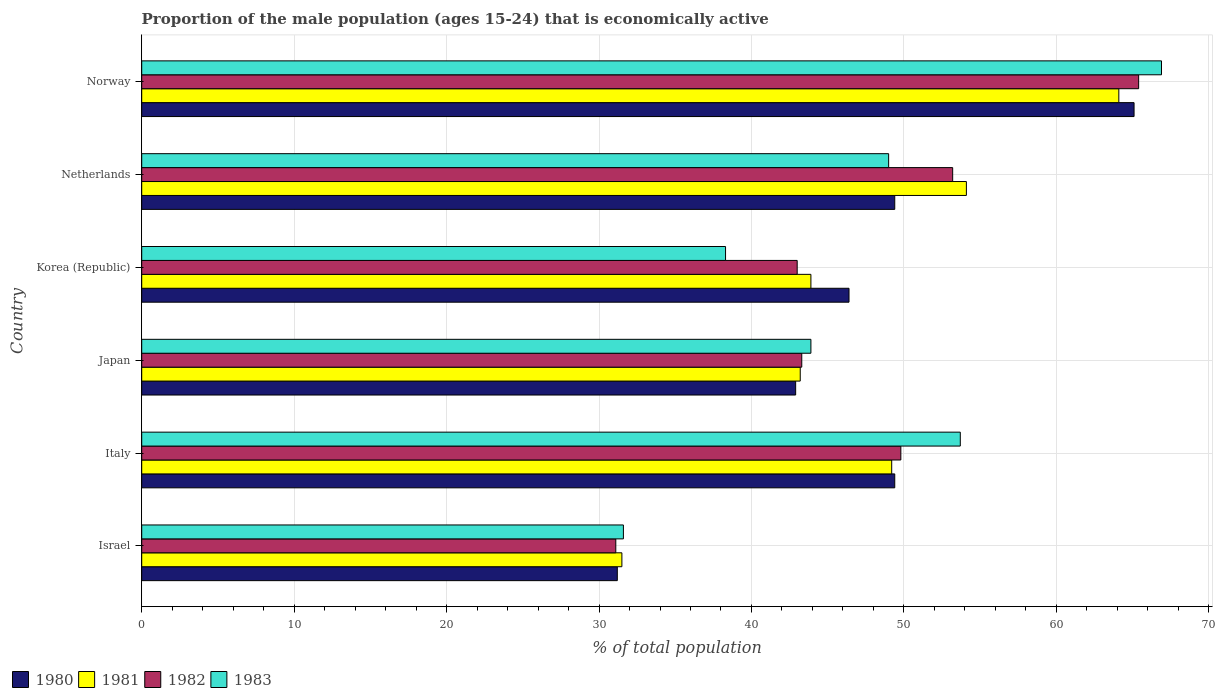How many different coloured bars are there?
Offer a terse response. 4. How many groups of bars are there?
Provide a succinct answer. 6. Are the number of bars per tick equal to the number of legend labels?
Your response must be concise. Yes. How many bars are there on the 3rd tick from the top?
Your answer should be compact. 4. What is the proportion of the male population that is economically active in 1980 in Israel?
Provide a succinct answer. 31.2. Across all countries, what is the maximum proportion of the male population that is economically active in 1983?
Provide a succinct answer. 66.9. Across all countries, what is the minimum proportion of the male population that is economically active in 1980?
Your answer should be very brief. 31.2. In which country was the proportion of the male population that is economically active in 1980 maximum?
Your answer should be very brief. Norway. In which country was the proportion of the male population that is economically active in 1983 minimum?
Provide a succinct answer. Israel. What is the total proportion of the male population that is economically active in 1981 in the graph?
Your response must be concise. 286. What is the difference between the proportion of the male population that is economically active in 1981 in Israel and that in Netherlands?
Give a very brief answer. -22.6. What is the difference between the proportion of the male population that is economically active in 1981 in Italy and the proportion of the male population that is economically active in 1983 in Norway?
Ensure brevity in your answer.  -17.7. What is the average proportion of the male population that is economically active in 1980 per country?
Keep it short and to the point. 47.4. What is the difference between the proportion of the male population that is economically active in 1982 and proportion of the male population that is economically active in 1983 in Norway?
Make the answer very short. -1.5. What is the ratio of the proportion of the male population that is economically active in 1982 in Japan to that in Korea (Republic)?
Provide a short and direct response. 1.01. Is the proportion of the male population that is economically active in 1981 in Italy less than that in Japan?
Keep it short and to the point. No. Is the difference between the proportion of the male population that is economically active in 1982 in Italy and Japan greater than the difference between the proportion of the male population that is economically active in 1983 in Italy and Japan?
Keep it short and to the point. No. What is the difference between the highest and the second highest proportion of the male population that is economically active in 1983?
Make the answer very short. 13.2. What is the difference between the highest and the lowest proportion of the male population that is economically active in 1982?
Provide a succinct answer. 34.3. In how many countries, is the proportion of the male population that is economically active in 1983 greater than the average proportion of the male population that is economically active in 1983 taken over all countries?
Your answer should be compact. 3. Is the sum of the proportion of the male population that is economically active in 1983 in Israel and Japan greater than the maximum proportion of the male population that is economically active in 1982 across all countries?
Provide a short and direct response. Yes. Is it the case that in every country, the sum of the proportion of the male population that is economically active in 1983 and proportion of the male population that is economically active in 1980 is greater than the sum of proportion of the male population that is economically active in 1981 and proportion of the male population that is economically active in 1982?
Provide a succinct answer. No. What does the 2nd bar from the top in Israel represents?
Make the answer very short. 1982. Are the values on the major ticks of X-axis written in scientific E-notation?
Your answer should be very brief. No. Does the graph contain grids?
Offer a terse response. Yes. How are the legend labels stacked?
Provide a succinct answer. Horizontal. What is the title of the graph?
Your answer should be very brief. Proportion of the male population (ages 15-24) that is economically active. What is the label or title of the X-axis?
Your answer should be very brief. % of total population. What is the label or title of the Y-axis?
Ensure brevity in your answer.  Country. What is the % of total population in 1980 in Israel?
Your answer should be very brief. 31.2. What is the % of total population in 1981 in Israel?
Provide a short and direct response. 31.5. What is the % of total population in 1982 in Israel?
Your answer should be compact. 31.1. What is the % of total population of 1983 in Israel?
Give a very brief answer. 31.6. What is the % of total population in 1980 in Italy?
Ensure brevity in your answer.  49.4. What is the % of total population in 1981 in Italy?
Give a very brief answer. 49.2. What is the % of total population in 1982 in Italy?
Keep it short and to the point. 49.8. What is the % of total population in 1983 in Italy?
Your answer should be compact. 53.7. What is the % of total population in 1980 in Japan?
Make the answer very short. 42.9. What is the % of total population of 1981 in Japan?
Provide a succinct answer. 43.2. What is the % of total population of 1982 in Japan?
Provide a succinct answer. 43.3. What is the % of total population in 1983 in Japan?
Offer a very short reply. 43.9. What is the % of total population in 1980 in Korea (Republic)?
Make the answer very short. 46.4. What is the % of total population in 1981 in Korea (Republic)?
Provide a succinct answer. 43.9. What is the % of total population in 1982 in Korea (Republic)?
Give a very brief answer. 43. What is the % of total population in 1983 in Korea (Republic)?
Ensure brevity in your answer.  38.3. What is the % of total population in 1980 in Netherlands?
Keep it short and to the point. 49.4. What is the % of total population in 1981 in Netherlands?
Your answer should be compact. 54.1. What is the % of total population in 1982 in Netherlands?
Provide a succinct answer. 53.2. What is the % of total population of 1983 in Netherlands?
Provide a short and direct response. 49. What is the % of total population of 1980 in Norway?
Provide a succinct answer. 65.1. What is the % of total population in 1981 in Norway?
Your answer should be compact. 64.1. What is the % of total population in 1982 in Norway?
Provide a succinct answer. 65.4. What is the % of total population in 1983 in Norway?
Your response must be concise. 66.9. Across all countries, what is the maximum % of total population of 1980?
Provide a short and direct response. 65.1. Across all countries, what is the maximum % of total population of 1981?
Give a very brief answer. 64.1. Across all countries, what is the maximum % of total population in 1982?
Ensure brevity in your answer.  65.4. Across all countries, what is the maximum % of total population of 1983?
Provide a short and direct response. 66.9. Across all countries, what is the minimum % of total population of 1980?
Your answer should be compact. 31.2. Across all countries, what is the minimum % of total population of 1981?
Offer a very short reply. 31.5. Across all countries, what is the minimum % of total population in 1982?
Keep it short and to the point. 31.1. Across all countries, what is the minimum % of total population of 1983?
Ensure brevity in your answer.  31.6. What is the total % of total population in 1980 in the graph?
Keep it short and to the point. 284.4. What is the total % of total population of 1981 in the graph?
Give a very brief answer. 286. What is the total % of total population in 1982 in the graph?
Give a very brief answer. 285.8. What is the total % of total population of 1983 in the graph?
Provide a short and direct response. 283.4. What is the difference between the % of total population in 1980 in Israel and that in Italy?
Offer a very short reply. -18.2. What is the difference between the % of total population in 1981 in Israel and that in Italy?
Give a very brief answer. -17.7. What is the difference between the % of total population in 1982 in Israel and that in Italy?
Offer a terse response. -18.7. What is the difference between the % of total population of 1983 in Israel and that in Italy?
Keep it short and to the point. -22.1. What is the difference between the % of total population of 1980 in Israel and that in Japan?
Your answer should be compact. -11.7. What is the difference between the % of total population of 1981 in Israel and that in Japan?
Give a very brief answer. -11.7. What is the difference between the % of total population of 1982 in Israel and that in Japan?
Offer a terse response. -12.2. What is the difference between the % of total population in 1983 in Israel and that in Japan?
Your answer should be very brief. -12.3. What is the difference between the % of total population in 1980 in Israel and that in Korea (Republic)?
Your answer should be compact. -15.2. What is the difference between the % of total population of 1982 in Israel and that in Korea (Republic)?
Give a very brief answer. -11.9. What is the difference between the % of total population in 1983 in Israel and that in Korea (Republic)?
Ensure brevity in your answer.  -6.7. What is the difference between the % of total population in 1980 in Israel and that in Netherlands?
Make the answer very short. -18.2. What is the difference between the % of total population in 1981 in Israel and that in Netherlands?
Make the answer very short. -22.6. What is the difference between the % of total population in 1982 in Israel and that in Netherlands?
Make the answer very short. -22.1. What is the difference between the % of total population in 1983 in Israel and that in Netherlands?
Ensure brevity in your answer.  -17.4. What is the difference between the % of total population of 1980 in Israel and that in Norway?
Keep it short and to the point. -33.9. What is the difference between the % of total population in 1981 in Israel and that in Norway?
Your answer should be very brief. -32.6. What is the difference between the % of total population of 1982 in Israel and that in Norway?
Offer a terse response. -34.3. What is the difference between the % of total population of 1983 in Israel and that in Norway?
Your answer should be compact. -35.3. What is the difference between the % of total population of 1980 in Italy and that in Japan?
Offer a very short reply. 6.5. What is the difference between the % of total population of 1982 in Italy and that in Japan?
Make the answer very short. 6.5. What is the difference between the % of total population in 1983 in Italy and that in Japan?
Your response must be concise. 9.8. What is the difference between the % of total population of 1980 in Italy and that in Korea (Republic)?
Offer a terse response. 3. What is the difference between the % of total population in 1983 in Italy and that in Netherlands?
Make the answer very short. 4.7. What is the difference between the % of total population in 1980 in Italy and that in Norway?
Provide a short and direct response. -15.7. What is the difference between the % of total population of 1981 in Italy and that in Norway?
Make the answer very short. -14.9. What is the difference between the % of total population of 1982 in Italy and that in Norway?
Provide a succinct answer. -15.6. What is the difference between the % of total population of 1981 in Japan and that in Korea (Republic)?
Ensure brevity in your answer.  -0.7. What is the difference between the % of total population in 1982 in Japan and that in Korea (Republic)?
Your response must be concise. 0.3. What is the difference between the % of total population in 1982 in Japan and that in Netherlands?
Provide a short and direct response. -9.9. What is the difference between the % of total population of 1983 in Japan and that in Netherlands?
Your answer should be very brief. -5.1. What is the difference between the % of total population in 1980 in Japan and that in Norway?
Your answer should be compact. -22.2. What is the difference between the % of total population in 1981 in Japan and that in Norway?
Provide a short and direct response. -20.9. What is the difference between the % of total population in 1982 in Japan and that in Norway?
Offer a very short reply. -22.1. What is the difference between the % of total population in 1981 in Korea (Republic) and that in Netherlands?
Give a very brief answer. -10.2. What is the difference between the % of total population of 1982 in Korea (Republic) and that in Netherlands?
Keep it short and to the point. -10.2. What is the difference between the % of total population of 1980 in Korea (Republic) and that in Norway?
Keep it short and to the point. -18.7. What is the difference between the % of total population in 1981 in Korea (Republic) and that in Norway?
Offer a very short reply. -20.2. What is the difference between the % of total population of 1982 in Korea (Republic) and that in Norway?
Your answer should be very brief. -22.4. What is the difference between the % of total population in 1983 in Korea (Republic) and that in Norway?
Keep it short and to the point. -28.6. What is the difference between the % of total population of 1980 in Netherlands and that in Norway?
Provide a succinct answer. -15.7. What is the difference between the % of total population in 1981 in Netherlands and that in Norway?
Give a very brief answer. -10. What is the difference between the % of total population in 1983 in Netherlands and that in Norway?
Provide a short and direct response. -17.9. What is the difference between the % of total population in 1980 in Israel and the % of total population in 1982 in Italy?
Offer a very short reply. -18.6. What is the difference between the % of total population in 1980 in Israel and the % of total population in 1983 in Italy?
Ensure brevity in your answer.  -22.5. What is the difference between the % of total population in 1981 in Israel and the % of total population in 1982 in Italy?
Ensure brevity in your answer.  -18.3. What is the difference between the % of total population of 1981 in Israel and the % of total population of 1983 in Italy?
Provide a short and direct response. -22.2. What is the difference between the % of total population in 1982 in Israel and the % of total population in 1983 in Italy?
Give a very brief answer. -22.6. What is the difference between the % of total population in 1980 in Israel and the % of total population in 1981 in Japan?
Provide a succinct answer. -12. What is the difference between the % of total population in 1980 in Israel and the % of total population in 1982 in Japan?
Provide a succinct answer. -12.1. What is the difference between the % of total population of 1981 in Israel and the % of total population of 1983 in Japan?
Ensure brevity in your answer.  -12.4. What is the difference between the % of total population in 1982 in Israel and the % of total population in 1983 in Japan?
Provide a succinct answer. -12.8. What is the difference between the % of total population of 1980 in Israel and the % of total population of 1981 in Korea (Republic)?
Your answer should be very brief. -12.7. What is the difference between the % of total population of 1980 in Israel and the % of total population of 1983 in Korea (Republic)?
Your answer should be compact. -7.1. What is the difference between the % of total population of 1982 in Israel and the % of total population of 1983 in Korea (Republic)?
Your answer should be very brief. -7.2. What is the difference between the % of total population in 1980 in Israel and the % of total population in 1981 in Netherlands?
Make the answer very short. -22.9. What is the difference between the % of total population in 1980 in Israel and the % of total population in 1983 in Netherlands?
Offer a terse response. -17.8. What is the difference between the % of total population of 1981 in Israel and the % of total population of 1982 in Netherlands?
Your answer should be compact. -21.7. What is the difference between the % of total population of 1981 in Israel and the % of total population of 1983 in Netherlands?
Give a very brief answer. -17.5. What is the difference between the % of total population in 1982 in Israel and the % of total population in 1983 in Netherlands?
Ensure brevity in your answer.  -17.9. What is the difference between the % of total population in 1980 in Israel and the % of total population in 1981 in Norway?
Provide a succinct answer. -32.9. What is the difference between the % of total population of 1980 in Israel and the % of total population of 1982 in Norway?
Your answer should be compact. -34.2. What is the difference between the % of total population of 1980 in Israel and the % of total population of 1983 in Norway?
Make the answer very short. -35.7. What is the difference between the % of total population of 1981 in Israel and the % of total population of 1982 in Norway?
Offer a very short reply. -33.9. What is the difference between the % of total population of 1981 in Israel and the % of total population of 1983 in Norway?
Your answer should be very brief. -35.4. What is the difference between the % of total population of 1982 in Israel and the % of total population of 1983 in Norway?
Provide a succinct answer. -35.8. What is the difference between the % of total population in 1982 in Italy and the % of total population in 1983 in Japan?
Make the answer very short. 5.9. What is the difference between the % of total population of 1980 in Italy and the % of total population of 1981 in Korea (Republic)?
Provide a succinct answer. 5.5. What is the difference between the % of total population in 1980 in Italy and the % of total population in 1982 in Korea (Republic)?
Make the answer very short. 6.4. What is the difference between the % of total population of 1981 in Italy and the % of total population of 1983 in Korea (Republic)?
Your answer should be very brief. 10.9. What is the difference between the % of total population of 1980 in Italy and the % of total population of 1983 in Netherlands?
Your answer should be very brief. 0.4. What is the difference between the % of total population of 1981 in Italy and the % of total population of 1982 in Netherlands?
Provide a short and direct response. -4. What is the difference between the % of total population in 1981 in Italy and the % of total population in 1983 in Netherlands?
Your response must be concise. 0.2. What is the difference between the % of total population in 1980 in Italy and the % of total population in 1981 in Norway?
Keep it short and to the point. -14.7. What is the difference between the % of total population in 1980 in Italy and the % of total population in 1983 in Norway?
Your response must be concise. -17.5. What is the difference between the % of total population in 1981 in Italy and the % of total population in 1982 in Norway?
Your answer should be very brief. -16.2. What is the difference between the % of total population in 1981 in Italy and the % of total population in 1983 in Norway?
Provide a succinct answer. -17.7. What is the difference between the % of total population in 1982 in Italy and the % of total population in 1983 in Norway?
Ensure brevity in your answer.  -17.1. What is the difference between the % of total population in 1980 in Japan and the % of total population in 1982 in Korea (Republic)?
Provide a succinct answer. -0.1. What is the difference between the % of total population in 1980 in Japan and the % of total population in 1981 in Netherlands?
Offer a terse response. -11.2. What is the difference between the % of total population of 1980 in Japan and the % of total population of 1982 in Netherlands?
Offer a terse response. -10.3. What is the difference between the % of total population in 1980 in Japan and the % of total population in 1983 in Netherlands?
Your answer should be very brief. -6.1. What is the difference between the % of total population in 1981 in Japan and the % of total population in 1982 in Netherlands?
Give a very brief answer. -10. What is the difference between the % of total population of 1980 in Japan and the % of total population of 1981 in Norway?
Offer a very short reply. -21.2. What is the difference between the % of total population of 1980 in Japan and the % of total population of 1982 in Norway?
Ensure brevity in your answer.  -22.5. What is the difference between the % of total population of 1981 in Japan and the % of total population of 1982 in Norway?
Provide a short and direct response. -22.2. What is the difference between the % of total population in 1981 in Japan and the % of total population in 1983 in Norway?
Give a very brief answer. -23.7. What is the difference between the % of total population of 1982 in Japan and the % of total population of 1983 in Norway?
Make the answer very short. -23.6. What is the difference between the % of total population in 1980 in Korea (Republic) and the % of total population in 1982 in Netherlands?
Provide a short and direct response. -6.8. What is the difference between the % of total population of 1980 in Korea (Republic) and the % of total population of 1983 in Netherlands?
Your answer should be compact. -2.6. What is the difference between the % of total population of 1981 in Korea (Republic) and the % of total population of 1982 in Netherlands?
Keep it short and to the point. -9.3. What is the difference between the % of total population in 1982 in Korea (Republic) and the % of total population in 1983 in Netherlands?
Keep it short and to the point. -6. What is the difference between the % of total population in 1980 in Korea (Republic) and the % of total population in 1981 in Norway?
Provide a short and direct response. -17.7. What is the difference between the % of total population in 1980 in Korea (Republic) and the % of total population in 1983 in Norway?
Offer a terse response. -20.5. What is the difference between the % of total population in 1981 in Korea (Republic) and the % of total population in 1982 in Norway?
Provide a succinct answer. -21.5. What is the difference between the % of total population of 1982 in Korea (Republic) and the % of total population of 1983 in Norway?
Provide a succinct answer. -23.9. What is the difference between the % of total population in 1980 in Netherlands and the % of total population in 1981 in Norway?
Provide a short and direct response. -14.7. What is the difference between the % of total population in 1980 in Netherlands and the % of total population in 1983 in Norway?
Offer a terse response. -17.5. What is the difference between the % of total population in 1981 in Netherlands and the % of total population in 1982 in Norway?
Offer a terse response. -11.3. What is the difference between the % of total population of 1982 in Netherlands and the % of total population of 1983 in Norway?
Keep it short and to the point. -13.7. What is the average % of total population of 1980 per country?
Give a very brief answer. 47.4. What is the average % of total population of 1981 per country?
Make the answer very short. 47.67. What is the average % of total population of 1982 per country?
Ensure brevity in your answer.  47.63. What is the average % of total population of 1983 per country?
Offer a very short reply. 47.23. What is the difference between the % of total population in 1980 and % of total population in 1981 in Israel?
Make the answer very short. -0.3. What is the difference between the % of total population in 1980 and % of total population in 1983 in Israel?
Give a very brief answer. -0.4. What is the difference between the % of total population of 1981 and % of total population of 1982 in Israel?
Keep it short and to the point. 0.4. What is the difference between the % of total population of 1982 and % of total population of 1983 in Israel?
Your answer should be very brief. -0.5. What is the difference between the % of total population in 1980 and % of total population in 1982 in Italy?
Keep it short and to the point. -0.4. What is the difference between the % of total population in 1980 and % of total population in 1983 in Italy?
Ensure brevity in your answer.  -4.3. What is the difference between the % of total population in 1981 and % of total population in 1982 in Italy?
Your answer should be compact. -0.6. What is the difference between the % of total population in 1981 and % of total population in 1983 in Italy?
Your answer should be very brief. -4.5. What is the difference between the % of total population in 1982 and % of total population in 1983 in Italy?
Your answer should be very brief. -3.9. What is the difference between the % of total population in 1980 and % of total population in 1981 in Japan?
Your response must be concise. -0.3. What is the difference between the % of total population in 1981 and % of total population in 1982 in Japan?
Make the answer very short. -0.1. What is the difference between the % of total population in 1981 and % of total population in 1983 in Japan?
Offer a terse response. -0.7. What is the difference between the % of total population in 1982 and % of total population in 1983 in Japan?
Offer a very short reply. -0.6. What is the difference between the % of total population of 1980 and % of total population of 1983 in Korea (Republic)?
Provide a short and direct response. 8.1. What is the difference between the % of total population of 1981 and % of total population of 1983 in Korea (Republic)?
Your answer should be very brief. 5.6. What is the difference between the % of total population in 1980 and % of total population in 1981 in Netherlands?
Provide a succinct answer. -4.7. What is the difference between the % of total population in 1980 and % of total population in 1982 in Netherlands?
Keep it short and to the point. -3.8. What is the difference between the % of total population in 1981 and % of total population in 1983 in Netherlands?
Offer a very short reply. 5.1. What is the difference between the % of total population in 1980 and % of total population in 1981 in Norway?
Ensure brevity in your answer.  1. What is the difference between the % of total population of 1981 and % of total population of 1982 in Norway?
Your answer should be very brief. -1.3. What is the ratio of the % of total population of 1980 in Israel to that in Italy?
Your answer should be compact. 0.63. What is the ratio of the % of total population of 1981 in Israel to that in Italy?
Give a very brief answer. 0.64. What is the ratio of the % of total population of 1982 in Israel to that in Italy?
Offer a very short reply. 0.62. What is the ratio of the % of total population of 1983 in Israel to that in Italy?
Offer a terse response. 0.59. What is the ratio of the % of total population in 1980 in Israel to that in Japan?
Provide a succinct answer. 0.73. What is the ratio of the % of total population in 1981 in Israel to that in Japan?
Offer a very short reply. 0.73. What is the ratio of the % of total population in 1982 in Israel to that in Japan?
Provide a short and direct response. 0.72. What is the ratio of the % of total population in 1983 in Israel to that in Japan?
Give a very brief answer. 0.72. What is the ratio of the % of total population in 1980 in Israel to that in Korea (Republic)?
Offer a terse response. 0.67. What is the ratio of the % of total population in 1981 in Israel to that in Korea (Republic)?
Your answer should be compact. 0.72. What is the ratio of the % of total population of 1982 in Israel to that in Korea (Republic)?
Provide a short and direct response. 0.72. What is the ratio of the % of total population in 1983 in Israel to that in Korea (Republic)?
Give a very brief answer. 0.83. What is the ratio of the % of total population of 1980 in Israel to that in Netherlands?
Make the answer very short. 0.63. What is the ratio of the % of total population of 1981 in Israel to that in Netherlands?
Offer a very short reply. 0.58. What is the ratio of the % of total population of 1982 in Israel to that in Netherlands?
Offer a terse response. 0.58. What is the ratio of the % of total population of 1983 in Israel to that in Netherlands?
Keep it short and to the point. 0.64. What is the ratio of the % of total population in 1980 in Israel to that in Norway?
Your response must be concise. 0.48. What is the ratio of the % of total population of 1981 in Israel to that in Norway?
Offer a very short reply. 0.49. What is the ratio of the % of total population in 1982 in Israel to that in Norway?
Your response must be concise. 0.48. What is the ratio of the % of total population in 1983 in Israel to that in Norway?
Offer a very short reply. 0.47. What is the ratio of the % of total population in 1980 in Italy to that in Japan?
Ensure brevity in your answer.  1.15. What is the ratio of the % of total population of 1981 in Italy to that in Japan?
Provide a short and direct response. 1.14. What is the ratio of the % of total population in 1982 in Italy to that in Japan?
Keep it short and to the point. 1.15. What is the ratio of the % of total population of 1983 in Italy to that in Japan?
Your answer should be very brief. 1.22. What is the ratio of the % of total population in 1980 in Italy to that in Korea (Republic)?
Make the answer very short. 1.06. What is the ratio of the % of total population in 1981 in Italy to that in Korea (Republic)?
Provide a short and direct response. 1.12. What is the ratio of the % of total population of 1982 in Italy to that in Korea (Republic)?
Ensure brevity in your answer.  1.16. What is the ratio of the % of total population in 1983 in Italy to that in Korea (Republic)?
Provide a short and direct response. 1.4. What is the ratio of the % of total population in 1981 in Italy to that in Netherlands?
Ensure brevity in your answer.  0.91. What is the ratio of the % of total population in 1982 in Italy to that in Netherlands?
Keep it short and to the point. 0.94. What is the ratio of the % of total population of 1983 in Italy to that in Netherlands?
Give a very brief answer. 1.1. What is the ratio of the % of total population in 1980 in Italy to that in Norway?
Provide a succinct answer. 0.76. What is the ratio of the % of total population in 1981 in Italy to that in Norway?
Make the answer very short. 0.77. What is the ratio of the % of total population of 1982 in Italy to that in Norway?
Ensure brevity in your answer.  0.76. What is the ratio of the % of total population in 1983 in Italy to that in Norway?
Your answer should be very brief. 0.8. What is the ratio of the % of total population in 1980 in Japan to that in Korea (Republic)?
Provide a short and direct response. 0.92. What is the ratio of the % of total population in 1981 in Japan to that in Korea (Republic)?
Offer a terse response. 0.98. What is the ratio of the % of total population of 1982 in Japan to that in Korea (Republic)?
Give a very brief answer. 1.01. What is the ratio of the % of total population of 1983 in Japan to that in Korea (Republic)?
Your response must be concise. 1.15. What is the ratio of the % of total population in 1980 in Japan to that in Netherlands?
Ensure brevity in your answer.  0.87. What is the ratio of the % of total population in 1981 in Japan to that in Netherlands?
Offer a terse response. 0.8. What is the ratio of the % of total population in 1982 in Japan to that in Netherlands?
Offer a terse response. 0.81. What is the ratio of the % of total population of 1983 in Japan to that in Netherlands?
Offer a terse response. 0.9. What is the ratio of the % of total population of 1980 in Japan to that in Norway?
Give a very brief answer. 0.66. What is the ratio of the % of total population of 1981 in Japan to that in Norway?
Offer a terse response. 0.67. What is the ratio of the % of total population of 1982 in Japan to that in Norway?
Keep it short and to the point. 0.66. What is the ratio of the % of total population of 1983 in Japan to that in Norway?
Your response must be concise. 0.66. What is the ratio of the % of total population of 1980 in Korea (Republic) to that in Netherlands?
Give a very brief answer. 0.94. What is the ratio of the % of total population in 1981 in Korea (Republic) to that in Netherlands?
Provide a short and direct response. 0.81. What is the ratio of the % of total population in 1982 in Korea (Republic) to that in Netherlands?
Offer a terse response. 0.81. What is the ratio of the % of total population of 1983 in Korea (Republic) to that in Netherlands?
Your response must be concise. 0.78. What is the ratio of the % of total population of 1980 in Korea (Republic) to that in Norway?
Make the answer very short. 0.71. What is the ratio of the % of total population in 1981 in Korea (Republic) to that in Norway?
Ensure brevity in your answer.  0.68. What is the ratio of the % of total population of 1982 in Korea (Republic) to that in Norway?
Give a very brief answer. 0.66. What is the ratio of the % of total population in 1983 in Korea (Republic) to that in Norway?
Offer a terse response. 0.57. What is the ratio of the % of total population in 1980 in Netherlands to that in Norway?
Ensure brevity in your answer.  0.76. What is the ratio of the % of total population in 1981 in Netherlands to that in Norway?
Provide a succinct answer. 0.84. What is the ratio of the % of total population of 1982 in Netherlands to that in Norway?
Keep it short and to the point. 0.81. What is the ratio of the % of total population of 1983 in Netherlands to that in Norway?
Make the answer very short. 0.73. What is the difference between the highest and the second highest % of total population in 1980?
Keep it short and to the point. 15.7. What is the difference between the highest and the lowest % of total population of 1980?
Offer a very short reply. 33.9. What is the difference between the highest and the lowest % of total population in 1981?
Give a very brief answer. 32.6. What is the difference between the highest and the lowest % of total population in 1982?
Provide a short and direct response. 34.3. What is the difference between the highest and the lowest % of total population in 1983?
Make the answer very short. 35.3. 